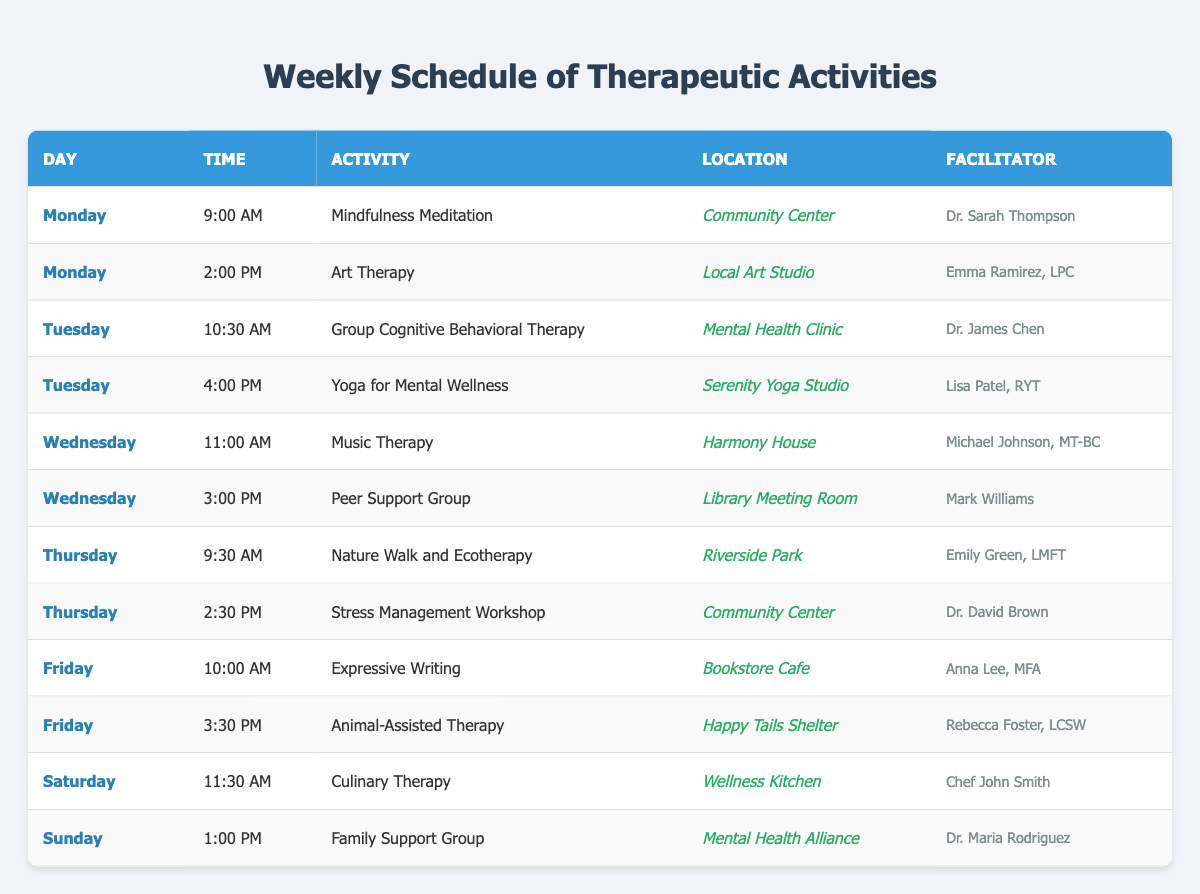What activities are scheduled for Wednesday? By examining the table for the day "Wednesday," we look at all rows corresponding to that day. There are two activities: "Music Therapy" at "11:00 AM," and "Peer Support Group" at "3:00 PM."
Answer: Music Therapy and Peer Support Group Who facilitates the Nature Walk and Ecotherapy session? Looking into the row where the activity is "Nature Walk and Ecotherapy," we can see it is scheduled for Thursday at "9:30 AM" and facilitated by "Emily Green, LMFT."
Answer: Emily Green, LMFT Are there any activities scheduled on Sunday? Checking the table for the day "Sunday," we find one activity: "Family Support Group," which is at "1:00 PM." Hence, there is at least one activity on this day.
Answer: Yes What time is the Yoga for Mental Wellness session? In the row that contains the activity "Yoga for Mental Wellness," we see it is scheduled for Tuesday at "4:00 PM."
Answer: 4:00 PM How many different facilitators are involved in the schedule? To determine the number of different facilitators, we also look through each row and compile the names of all facilitators: Dr. Sarah Thompson, Emma Ramirez, LPC, Dr. James Chen, Lisa Patel, RYT, Michael Johnson, MT-BC, Mark Williams, Emily Green, LMFT, Dr. David Brown, Anna Lee, MFA, Rebecca Foster, LCSW, Chef John Smith, and Dr. Maria Rodriguez. This totals to 11 unique facilitators.
Answer: 11 